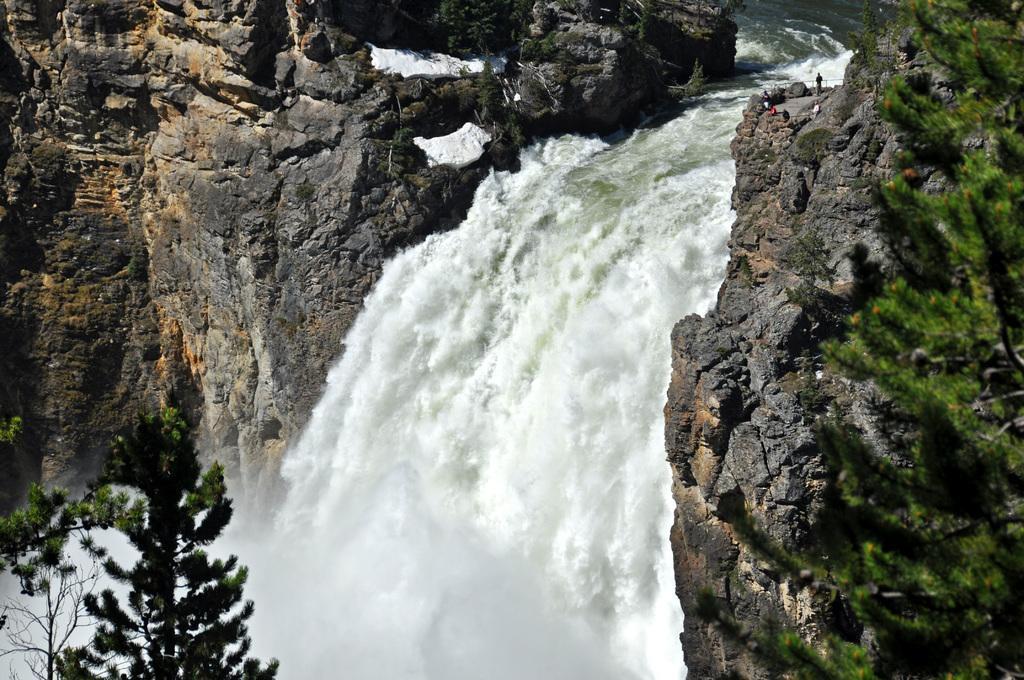Please provide a concise description of this image. This picture is taken from the outside of the city. In this image, in the left corner, we can see a tree. On the right side, we can also see another tree. On the right side, we can also see another tree. On the right side, we can also see a group of people, rocks. In the middle of the image, we can see a waterfall. In the background, we can see some rocks and a water. 